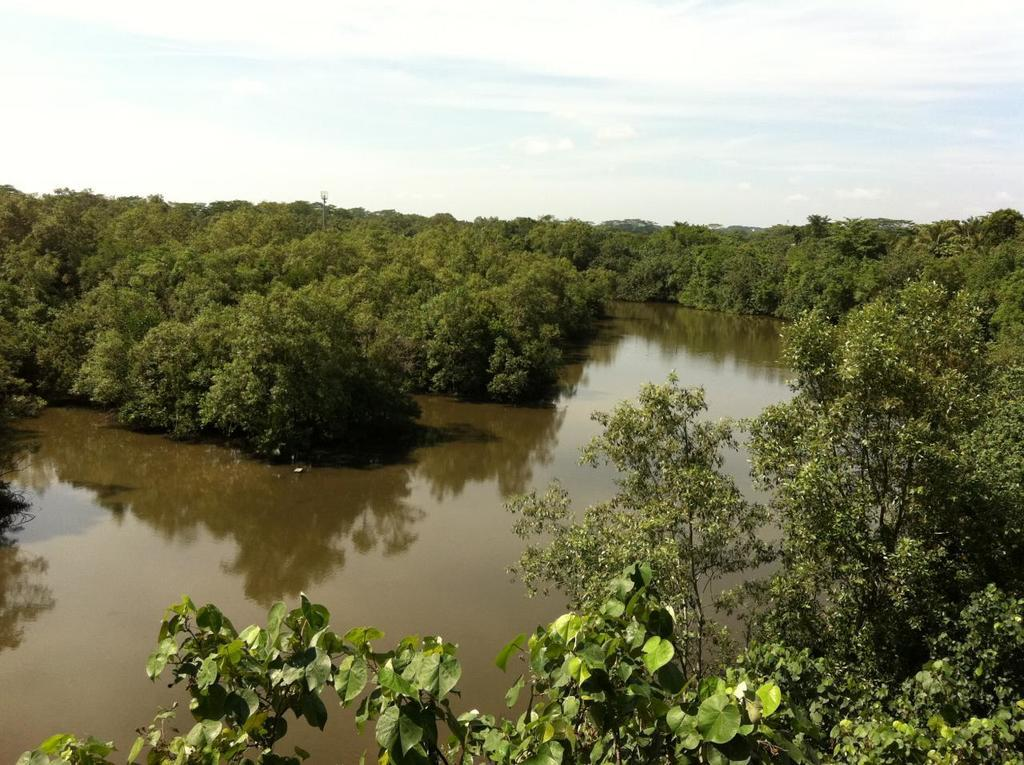What is the main feature of the image? There is a lake in the image. What can be seen around the lake? The lake is surrounded by trees and plants. What type of lipstick is being used to color the trees around the lake? There is no lipstick or any indication of coloring in the image; the trees are naturally colored. 